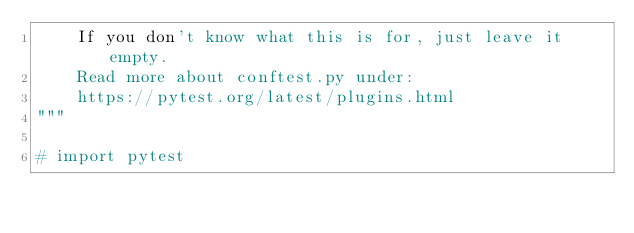Convert code to text. <code><loc_0><loc_0><loc_500><loc_500><_Python_>    If you don't know what this is for, just leave it empty.
    Read more about conftest.py under:
    https://pytest.org/latest/plugins.html
"""

# import pytest
</code> 